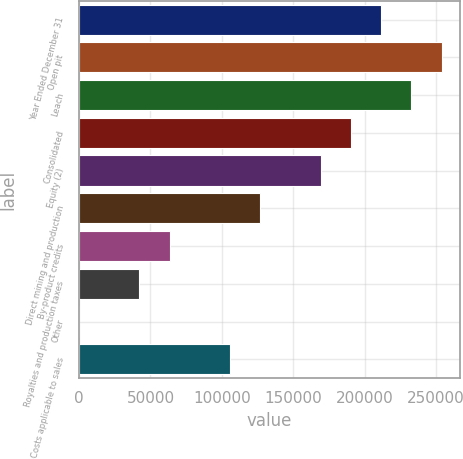Convert chart to OTSL. <chart><loc_0><loc_0><loc_500><loc_500><bar_chart><fcel>Year Ended December 31<fcel>Open pit<fcel>Leach<fcel>Consolidated<fcel>Equity (2)<fcel>Direct mining and production<fcel>By-product credits<fcel>Royalties and production taxes<fcel>Other<fcel>Costs applicable to sales<nl><fcel>211525<fcel>253829<fcel>232677<fcel>190373<fcel>169221<fcel>126916<fcel>63459.6<fcel>42307.4<fcel>3<fcel>105764<nl></chart> 